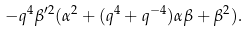<formula> <loc_0><loc_0><loc_500><loc_500>- q ^ { 4 } \beta ^ { \prime 2 } ( \alpha ^ { 2 } + ( q ^ { 4 } + q ^ { - 4 } ) \alpha \beta + \beta ^ { 2 } ) .</formula> 